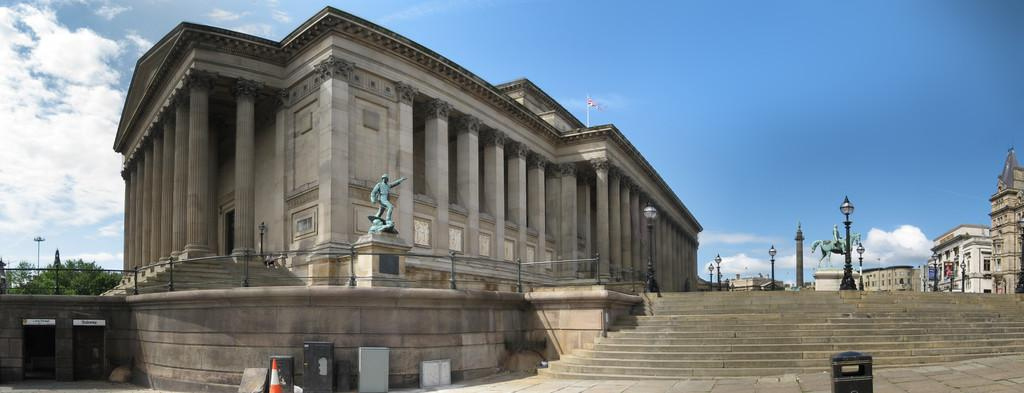What type of structures can be seen in the image? There are buildings in the image. What objects are present in the image that might be related to infrastructure? There are poles and lights visible in the image. What type of natural elements can be seen in the image? There are trees in the image. What object is present in the image that is commonly used for traffic control? There is a traffic cone in the image. What type of artistic elements can be seen in the image? There are sculptures in the image. What architectural feature is present in the image? There are stairs in the image. What can be seen in the background of the image? There is a flag, clouds, and sky visible in the background of the image. Where is the ring located in the image? There is no ring present in the image. What type of furniture can be seen in the image? There is no sofa present in the image. 